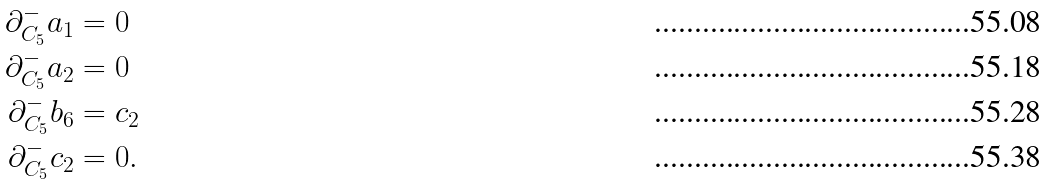Convert formula to latex. <formula><loc_0><loc_0><loc_500><loc_500>\partial _ { C _ { 5 } } ^ { - } a _ { 1 } & = 0 \\ \partial _ { C _ { 5 } } ^ { - } a _ { 2 } & = 0 \\ \partial _ { C _ { 5 } } ^ { - } b _ { 6 } & = c _ { 2 } \\ \partial _ { C _ { 5 } } ^ { - } c _ { 2 } & = 0 .</formula> 